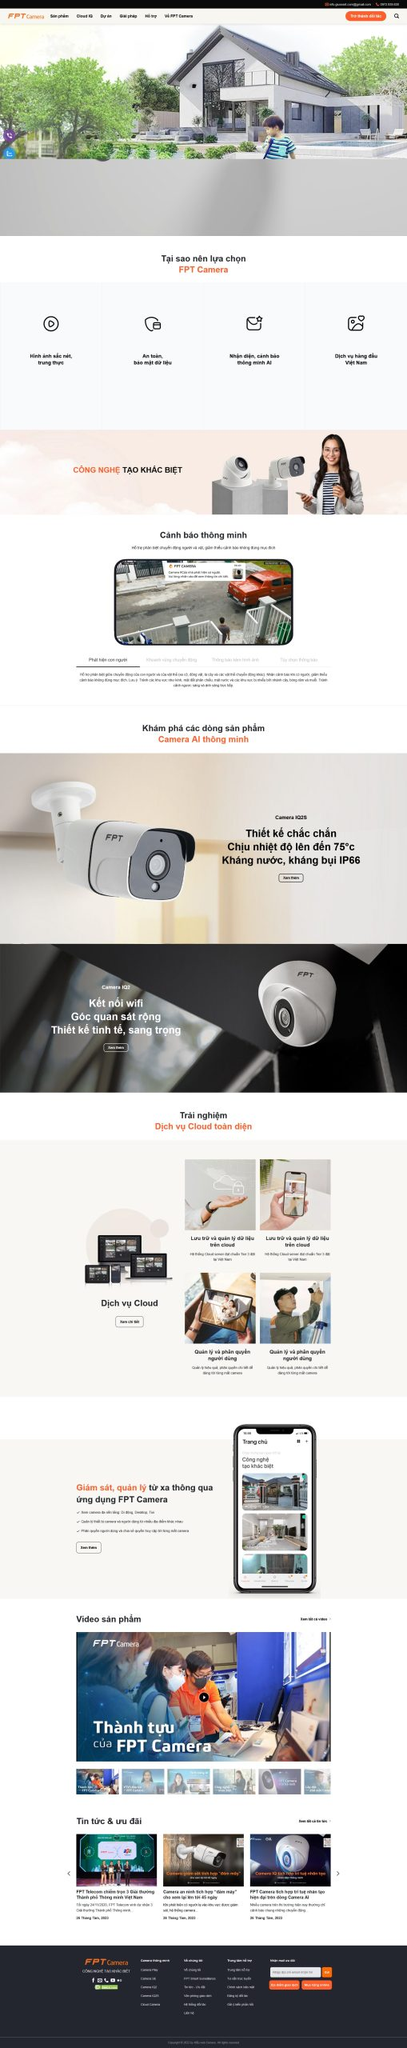Liệt kê 5 ngành nghề, lĩnh vực phù hợp với website này, phân cách các màu sắc bằng dấu phẩy. Chỉ trả về kết quả, phân cách bằng dấy phẩy
 Công nghệ, An ninh, Giám sát, Nhà thông minh, Dịch vụ đám mây 